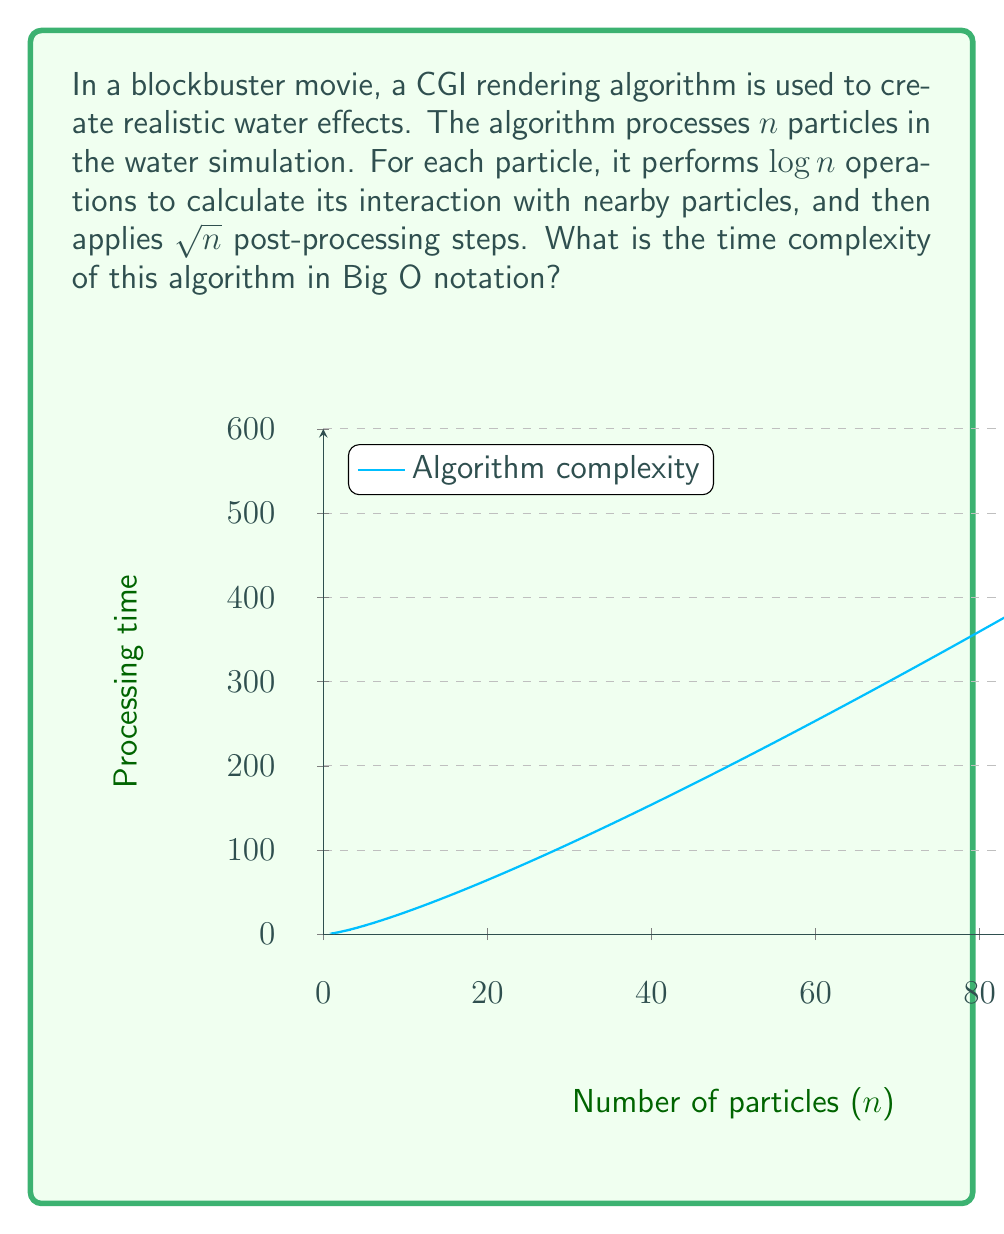Help me with this question. Let's break down the algorithm and analyze its time complexity step by step:

1. The algorithm processes $n$ particles.

2. For each particle, it performs $\log n$ operations:
   - This contributes $n \cdot \log n$ to the overall complexity.

3. After processing each particle, it applies $\sqrt{n}$ post-processing steps:
   - This contributes an additional $n \cdot \sqrt{n}$ to the complexity.

4. The total number of operations is thus:
   $T(n) = n \cdot \log n + n \cdot \sqrt{n}$

5. To determine the dominant term, we compare $\log n$ and $\sqrt{n}$:
   - For large $n$, $\sqrt{n}$ grows faster than $\log n$.

6. Therefore, $n \cdot \sqrt{n}$ is the dominant term.

7. In Big O notation, we express this as $O(n \cdot \sqrt{n})$ or $O(n^{1.5})$.

This complexity reflects that as the number of particles increases, the processing time grows faster than linear but slower than quadratic, which is typical for many CGI rendering algorithms balancing detail and performance.
Answer: $O(n^{1.5})$ 